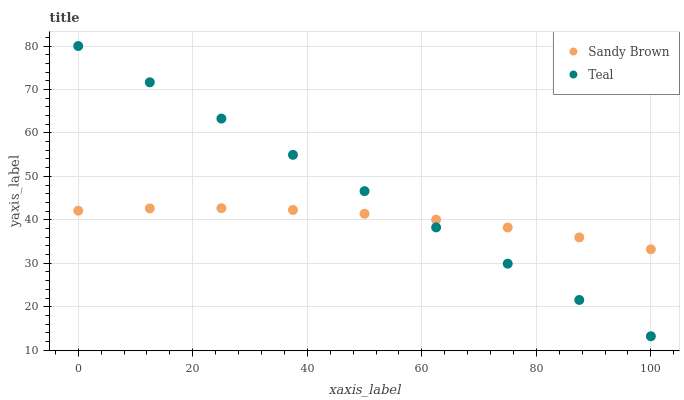Does Sandy Brown have the minimum area under the curve?
Answer yes or no. Yes. Does Teal have the maximum area under the curve?
Answer yes or no. Yes. Does Teal have the minimum area under the curve?
Answer yes or no. No. Is Teal the smoothest?
Answer yes or no. Yes. Is Sandy Brown the roughest?
Answer yes or no. Yes. Is Teal the roughest?
Answer yes or no. No. Does Teal have the lowest value?
Answer yes or no. Yes. Does Teal have the highest value?
Answer yes or no. Yes. Does Sandy Brown intersect Teal?
Answer yes or no. Yes. Is Sandy Brown less than Teal?
Answer yes or no. No. Is Sandy Brown greater than Teal?
Answer yes or no. No. 